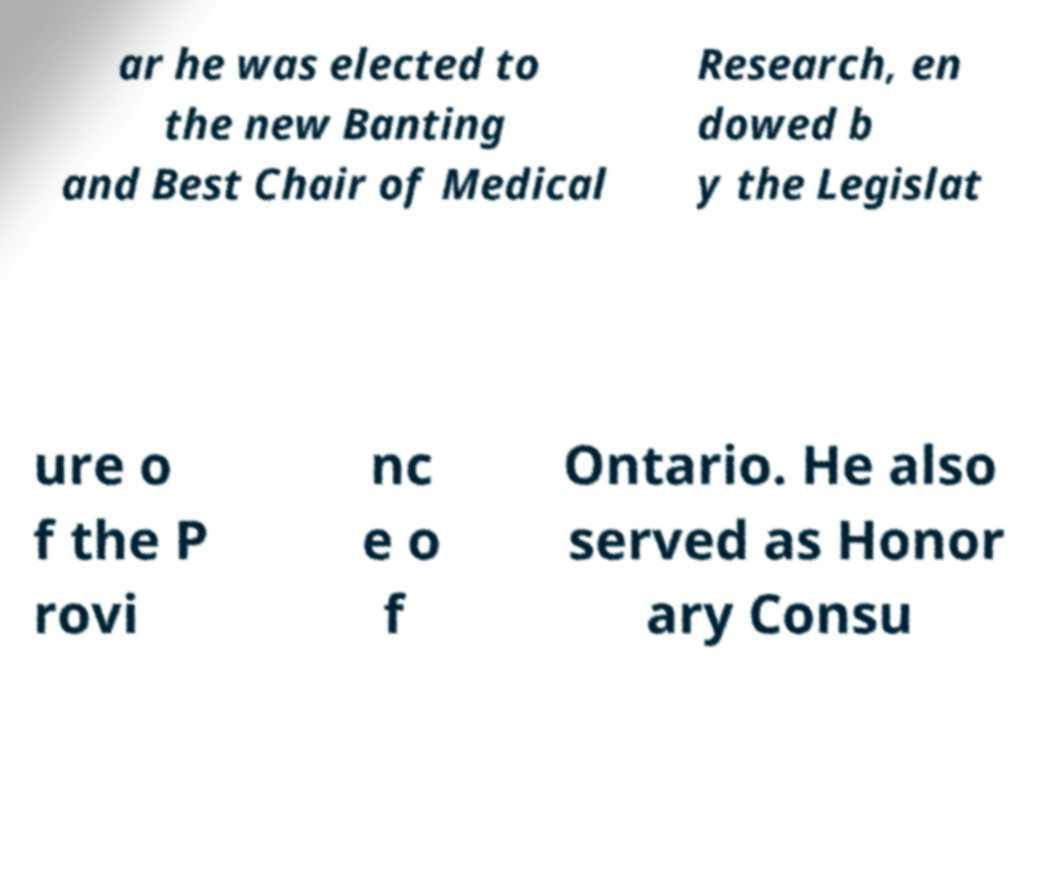Could you assist in decoding the text presented in this image and type it out clearly? ar he was elected to the new Banting and Best Chair of Medical Research, en dowed b y the Legislat ure o f the P rovi nc e o f Ontario. He also served as Honor ary Consu 